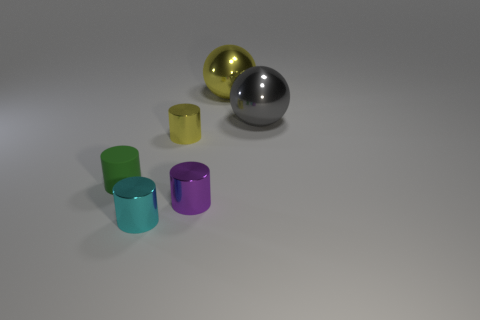Subtract all small shiny cylinders. How many cylinders are left? 1 Add 2 large shiny objects. How many objects exist? 8 Subtract all balls. How many objects are left? 4 Subtract 3 cylinders. How many cylinders are left? 1 Subtract all yellow spheres. How many spheres are left? 1 Subtract 0 green blocks. How many objects are left? 6 Subtract all brown cylinders. Subtract all cyan blocks. How many cylinders are left? 4 Subtract all big things. Subtract all tiny cylinders. How many objects are left? 0 Add 4 tiny matte cylinders. How many tiny matte cylinders are left? 5 Add 3 large objects. How many large objects exist? 5 